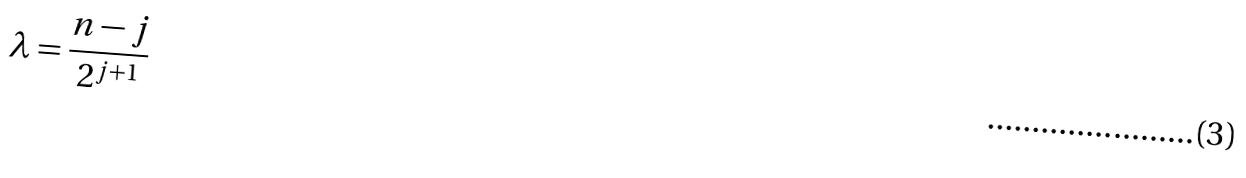Convert formula to latex. <formula><loc_0><loc_0><loc_500><loc_500>\lambda = \frac { n - j } { 2 ^ { j + 1 } }</formula> 